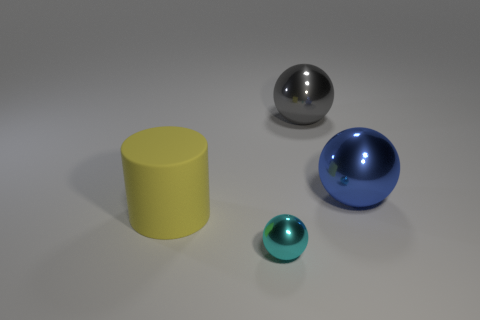Is there anything else that has the same material as the large yellow thing?
Keep it short and to the point. No. There is a big sphere that is in front of the large metal thing that is behind the large blue shiny thing; what color is it?
Keep it short and to the point. Blue. Is the gray sphere the same size as the cyan shiny sphere?
Keep it short and to the point. No. How many spheres are either tiny metallic objects or large blue shiny objects?
Give a very brief answer. 2. What number of large objects are left of the shiny thing that is in front of the rubber thing?
Keep it short and to the point. 1. Do the large blue thing and the matte thing have the same shape?
Offer a very short reply. No. What is the size of the blue object that is the same shape as the gray metal thing?
Give a very brief answer. Large. There is a metallic thing that is in front of the thing left of the tiny sphere; what shape is it?
Your answer should be compact. Sphere. The rubber thing is what size?
Your response must be concise. Large. What shape is the big yellow matte object?
Provide a short and direct response. Cylinder. 